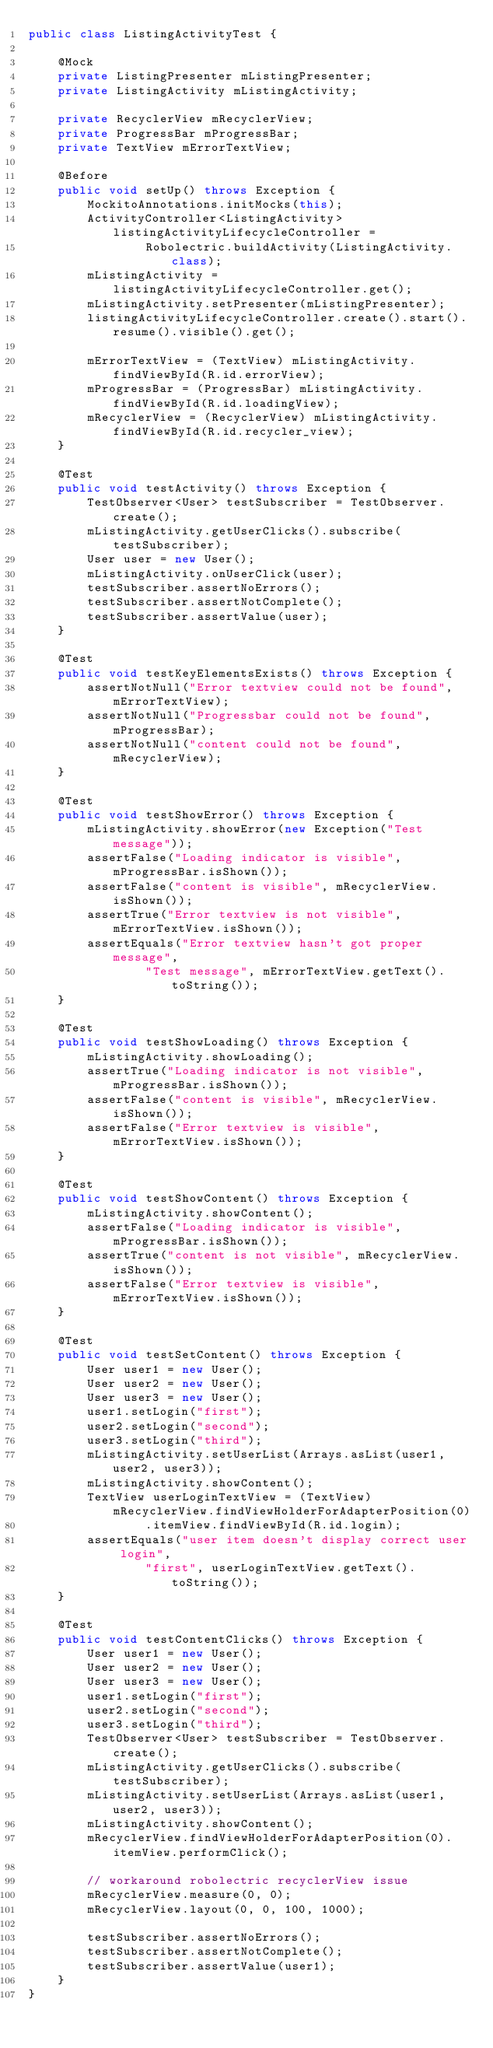Convert code to text. <code><loc_0><loc_0><loc_500><loc_500><_Java_>public class ListingActivityTest {

    @Mock
    private ListingPresenter mListingPresenter;
    private ListingActivity mListingActivity;

    private RecyclerView mRecyclerView;
    private ProgressBar mProgressBar;
    private TextView mErrorTextView;

    @Before
    public void setUp() throws Exception {
        MockitoAnnotations.initMocks(this);
        ActivityController<ListingActivity> listingActivityLifecycleController =
                Robolectric.buildActivity(ListingActivity.class);
        mListingActivity = listingActivityLifecycleController.get();
        mListingActivity.setPresenter(mListingPresenter);
        listingActivityLifecycleController.create().start().resume().visible().get();

        mErrorTextView = (TextView) mListingActivity.findViewById(R.id.errorView);
        mProgressBar = (ProgressBar) mListingActivity.findViewById(R.id.loadingView);
        mRecyclerView = (RecyclerView) mListingActivity.findViewById(R.id.recycler_view);
    }

    @Test
    public void testActivity() throws Exception {
        TestObserver<User> testSubscriber = TestObserver.create();
        mListingActivity.getUserClicks().subscribe(testSubscriber);
        User user = new User();
        mListingActivity.onUserClick(user);
        testSubscriber.assertNoErrors();
        testSubscriber.assertNotComplete();
        testSubscriber.assertValue(user);
    }

    @Test
    public void testKeyElementsExists() throws Exception {
        assertNotNull("Error textview could not be found", mErrorTextView);
        assertNotNull("Progressbar could not be found", mProgressBar);
        assertNotNull("content could not be found", mRecyclerView);
    }

    @Test
    public void testShowError() throws Exception {
        mListingActivity.showError(new Exception("Test message"));
        assertFalse("Loading indicator is visible", mProgressBar.isShown());
        assertFalse("content is visible", mRecyclerView.isShown());
        assertTrue("Error textview is not visible", mErrorTextView.isShown());
        assertEquals("Error textview hasn't got proper message",
                "Test message", mErrorTextView.getText().toString());
    }

    @Test
    public void testShowLoading() throws Exception {
        mListingActivity.showLoading();
        assertTrue("Loading indicator is not visible", mProgressBar.isShown());
        assertFalse("content is visible", mRecyclerView.isShown());
        assertFalse("Error textview is visible", mErrorTextView.isShown());
    }

    @Test
    public void testShowContent() throws Exception {
        mListingActivity.showContent();
        assertFalse("Loading indicator is visible", mProgressBar.isShown());
        assertTrue("content is not visible", mRecyclerView.isShown());
        assertFalse("Error textview is visible", mErrorTextView.isShown());
    }

    @Test
    public void testSetContent() throws Exception {
        User user1 = new User();
        User user2 = new User();
        User user3 = new User();
        user1.setLogin("first");
        user2.setLogin("second");
        user3.setLogin("third");
        mListingActivity.setUserList(Arrays.asList(user1, user2, user3));
        mListingActivity.showContent();
        TextView userLoginTextView = (TextView) mRecyclerView.findViewHolderForAdapterPosition(0)
                .itemView.findViewById(R.id.login);
        assertEquals("user item doesn't display correct user login",
                "first", userLoginTextView.getText().toString());
    }

    @Test
    public void testContentClicks() throws Exception {
        User user1 = new User();
        User user2 = new User();
        User user3 = new User();
        user1.setLogin("first");
        user2.setLogin("second");
        user3.setLogin("third");
        TestObserver<User> testSubscriber = TestObserver.create();
        mListingActivity.getUserClicks().subscribe(testSubscriber);
        mListingActivity.setUserList(Arrays.asList(user1, user2, user3));
        mListingActivity.showContent();
        mRecyclerView.findViewHolderForAdapterPosition(0).itemView.performClick();

        // workaround robolectric recyclerView issue
        mRecyclerView.measure(0, 0);
        mRecyclerView.layout(0, 0, 100, 1000);

        testSubscriber.assertNoErrors();
        testSubscriber.assertNotComplete();
        testSubscriber.assertValue(user1);
    }
}</code> 